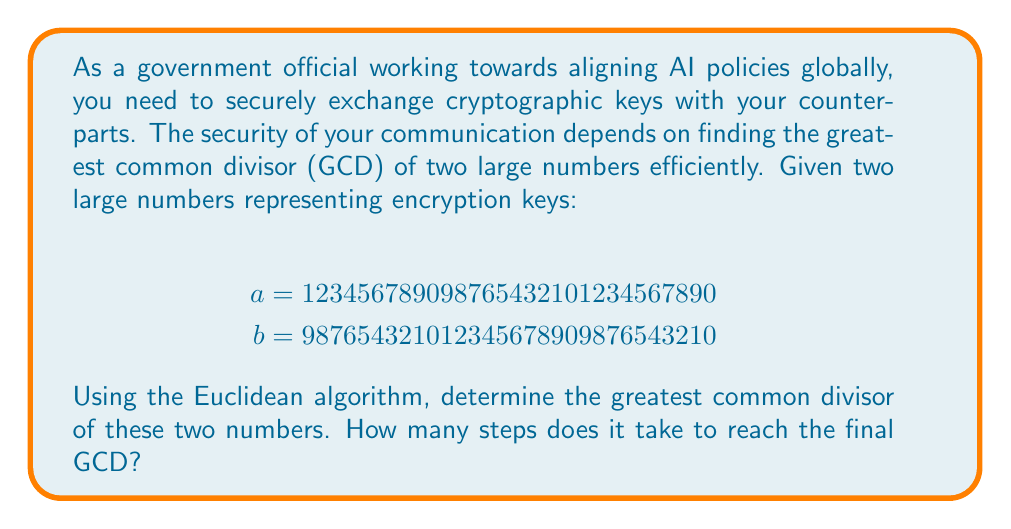Teach me how to tackle this problem. To find the GCD of these large numbers using the Euclidean algorithm, we follow these steps:

1) The Euclidean algorithm states that $GCD(a,b) = GCD(b, a \bmod b)$

2) We start with:
   $a = 123456789098765432101234567890$
   $b = 987654321012345678909876543210$

3) We perform the division algorithm:
   $a = 0 \times b + 123456789098765432101234567890$

4) Now we set $a = b$ and $b = a \bmod b$:
   $a = 987654321012345678909876543210$
   $b = 123456789098765432101234567890$

5) We repeat the process:
   $987654321012345678909876543210 = 8 \times 123456789098765432101234567890 + 0$

6) Since the remainder is 0, we stop here. The GCD is the last non-zero remainder, which is 123456789098765432101234567890.

The algorithm took 2 steps to reach the final GCD.

To verify, we can check if this number divides both original numbers:

$123456789098765432101234567890 \times 1 = 123456789098765432101234567890$
$123456789098765432101234567890 \times 8 = 987654321012345678909876543210$

Indeed, it does divide both numbers, confirming it is the GCD.
Answer: The greatest common divisor of 123456789098765432101234567890 and 987654321012345678909876543210 is 123456789098765432101234567890. The Euclidean algorithm took 2 steps to reach this result. 